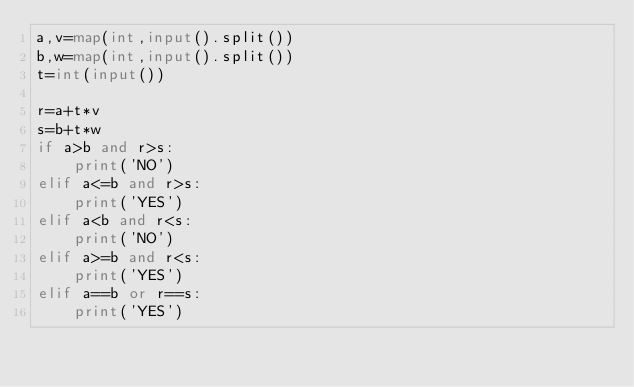<code> <loc_0><loc_0><loc_500><loc_500><_Python_>a,v=map(int,input().split())
b,w=map(int,input().split())
t=int(input())

r=a+t*v
s=b+t*w
if a>b and r>s:
    print('NO')
elif a<=b and r>s:
    print('YES')
elif a<b and r<s:
    print('NO')
elif a>=b and r<s:
    print('YES')
elif a==b or r==s:
    print('YES')
</code> 